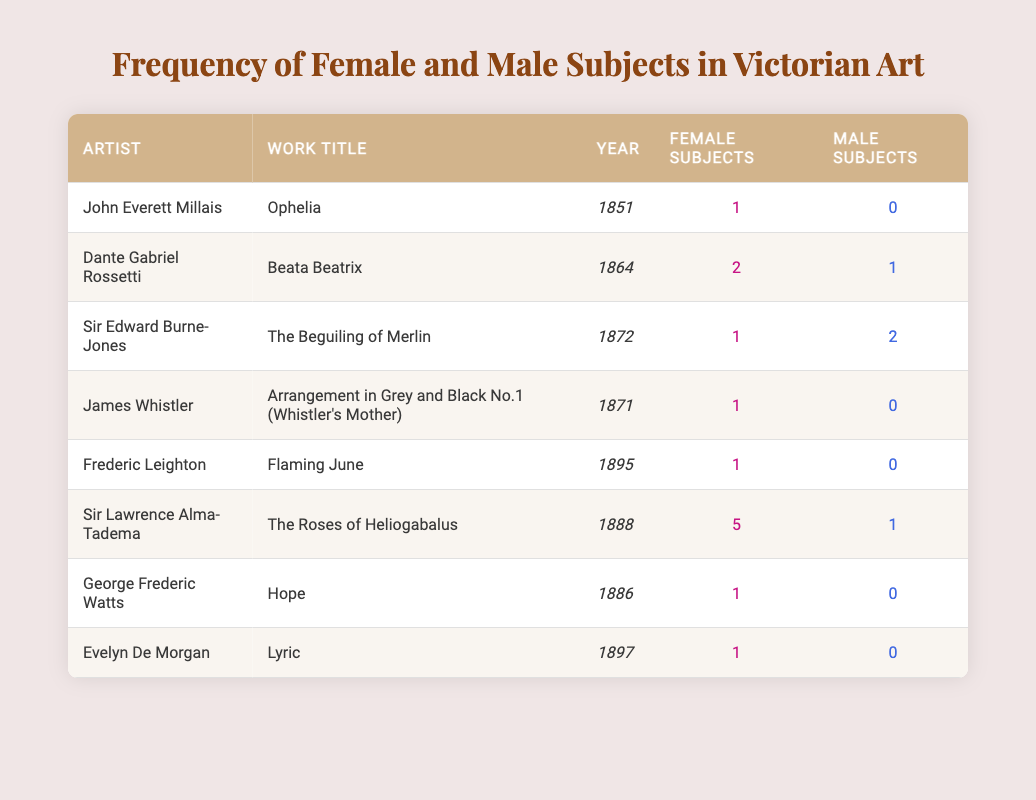What is the title of the artwork by John Everett Millais? In the table, under the artist column, the entry for John Everett Millais shows "Ophelia" in the work title column.
Answer: Ophelia How many female subjects are depicted in "The Roses of Heliogabalus" by Sir Lawrence Alma-Tadema? The table indicates that in "The Roses of Heliogabalus," there are 5 female subjects recorded under the female subjects column next to the artist's name.
Answer: 5 Which artist has only male subjects in their featured work? Looking through the table, Sir Edward Burne-Jones in the entry for "The Beguiling of Merlin" has 2 male subjects and 1 female subject; however, James Whistler and Frederic Leighton have works with only 1 female subject each and no male subjects. Thus, James Whistler's work is the answer.
Answer: James Whistler What is the total number of female subjects across all works listed? We add the number of female subjects from each row: 1 + 2 + 1 + 1 + 1 + 5 + 1 + 1 = 13. The total is 13 female subjects recording in the table.
Answer: 13 Is it true that all artists listed have at least one female subject in their works? By reviewing each entry in the table, we find that all except for Sir Edward Burne-Jones have at least one female subject, but he also has a female subject in his mentioned work. Therefore, it is true that all artists have at least one female subject.
Answer: Yes How does the frequency of male subjects compare to female subjects for Frederic Leighton? In the entry for Frederic Leighton, there is 1 female subject and 0 male subjects. The comparison shows a higher frequency of female subjects than male, specifically a ratio of 1:0.
Answer: Female subjects are more frequent What percentage of the total subjects are female subjects? We first calculate the total number of subjects by adding the female and male subjects for all entries: (13 female + 6 male) = 19 total subjects. The percentage of female subjects is (13/19) * 100 ≈ 68.42%.
Answer: Approximately 68.42% Which year had the artwork with the highest number of female subjects? By examining the years listed for their respective artworks, we see that "The Roses of Heliogabalus" in 1888 has the highest count of female subjects with 5. Thus, 1888 is the year with the highest number of female subjects.
Answer: 1888 What is the average number of male subjects across all the works? To find the average, we calculate the total number of male subjects as 0 + 1 + 2 + 0 + 0 + 1 + 0 + 0 = 4. There are 8 artworks, so the average is 4/8 = 0.5.
Answer: 0.5 